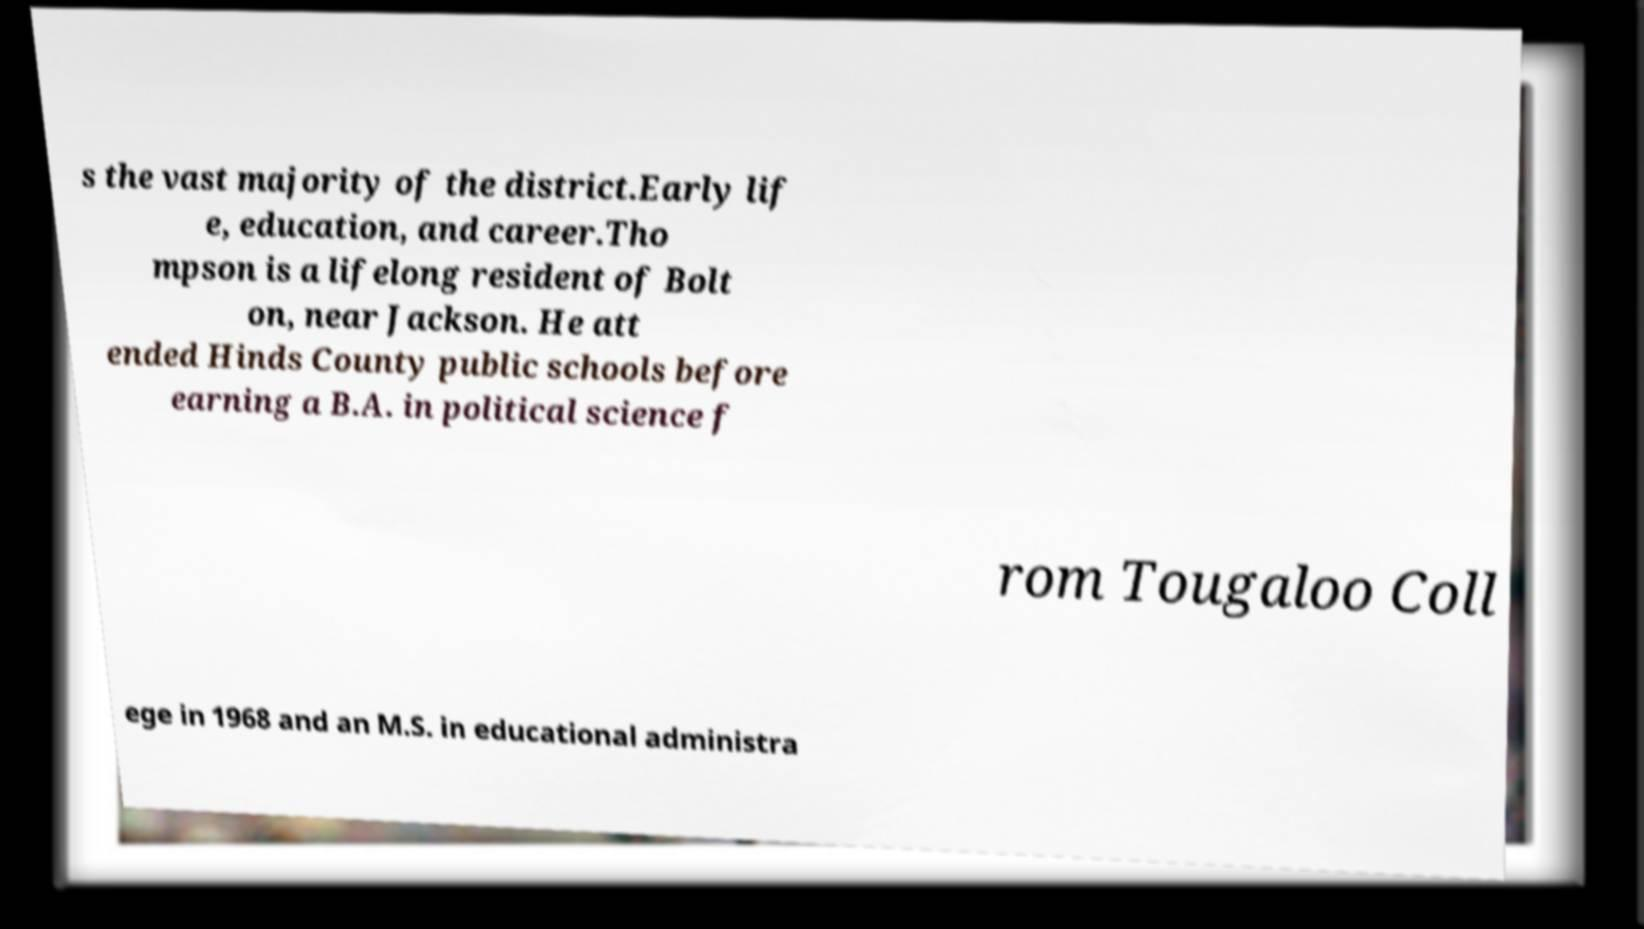There's text embedded in this image that I need extracted. Can you transcribe it verbatim? s the vast majority of the district.Early lif e, education, and career.Tho mpson is a lifelong resident of Bolt on, near Jackson. He att ended Hinds County public schools before earning a B.A. in political science f rom Tougaloo Coll ege in 1968 and an M.S. in educational administra 